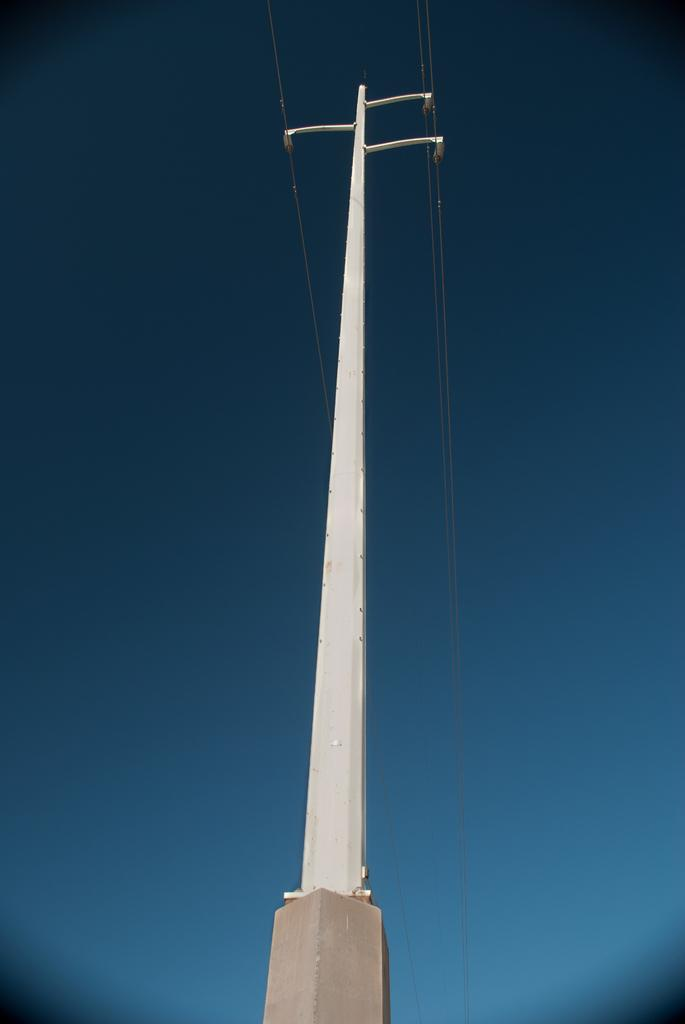What is the main object in the center of the image? There is a pole in the center of the image. Are there any additional features attached to the pole? Yes, there are wires attached to the pole. What type of scarecrow is sitting on the window ledge in the image? There is no scarecrow or window ledge present in the image; it only features a pole with wires attached. 